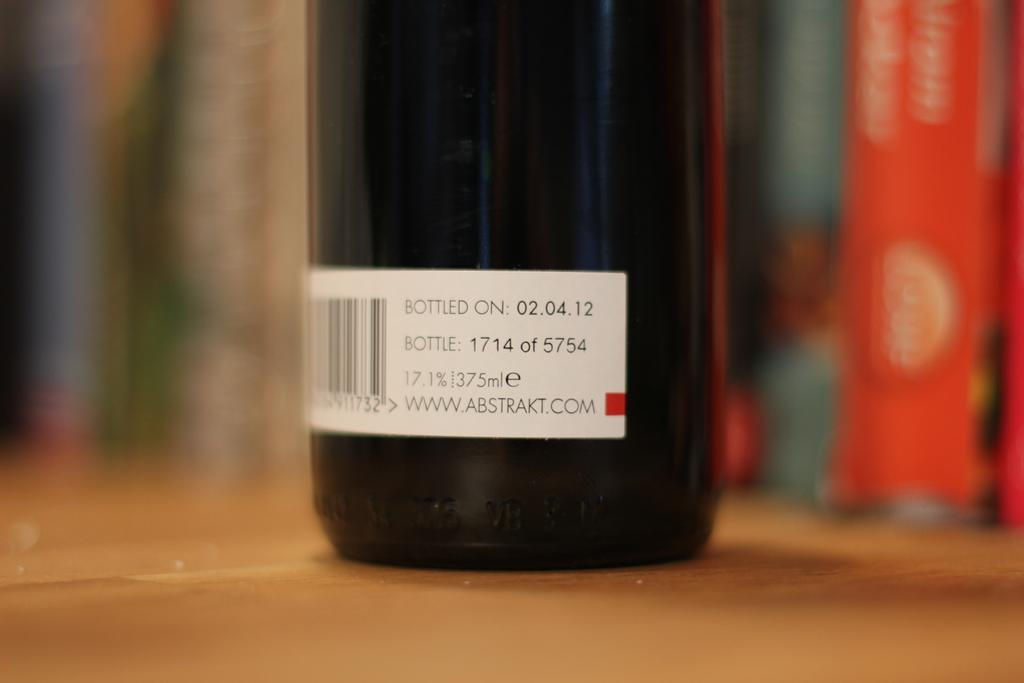Provide a one-sentence caption for the provided image. The label on a bottle states that it was bottled on "02.04.12.". 